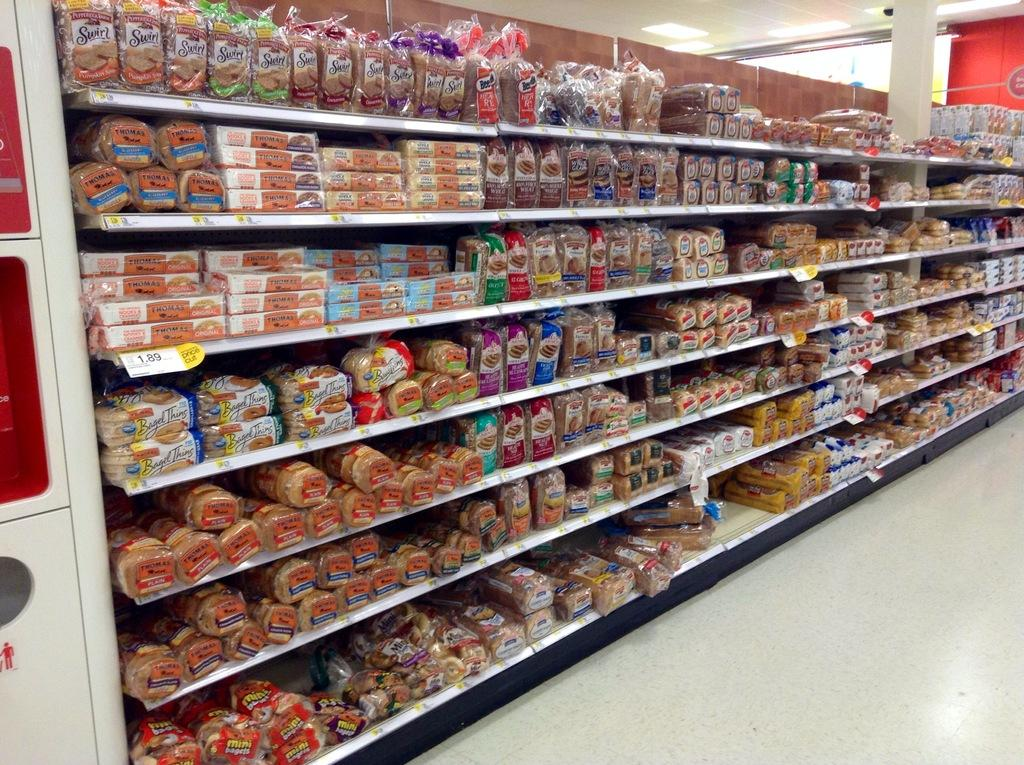What is stored on the racks in the image? There are racks with bread packets in the image. What else can be seen on the racks besides bread packets? There are other items on the racks. What is located on the right side of the image? There is a pillar on the right side of the image. What is the color of the object in the image? There is a white object in the image. What is present on the ceiling in the image? There are lights on the ceiling in the image. What type of pen can be seen in the image? There is no pen present in the image. How does the acoustics of the room affect the sound in the image? The image does not provide any information about the acoustics of the room, so it cannot be determined how they affect the sound. 